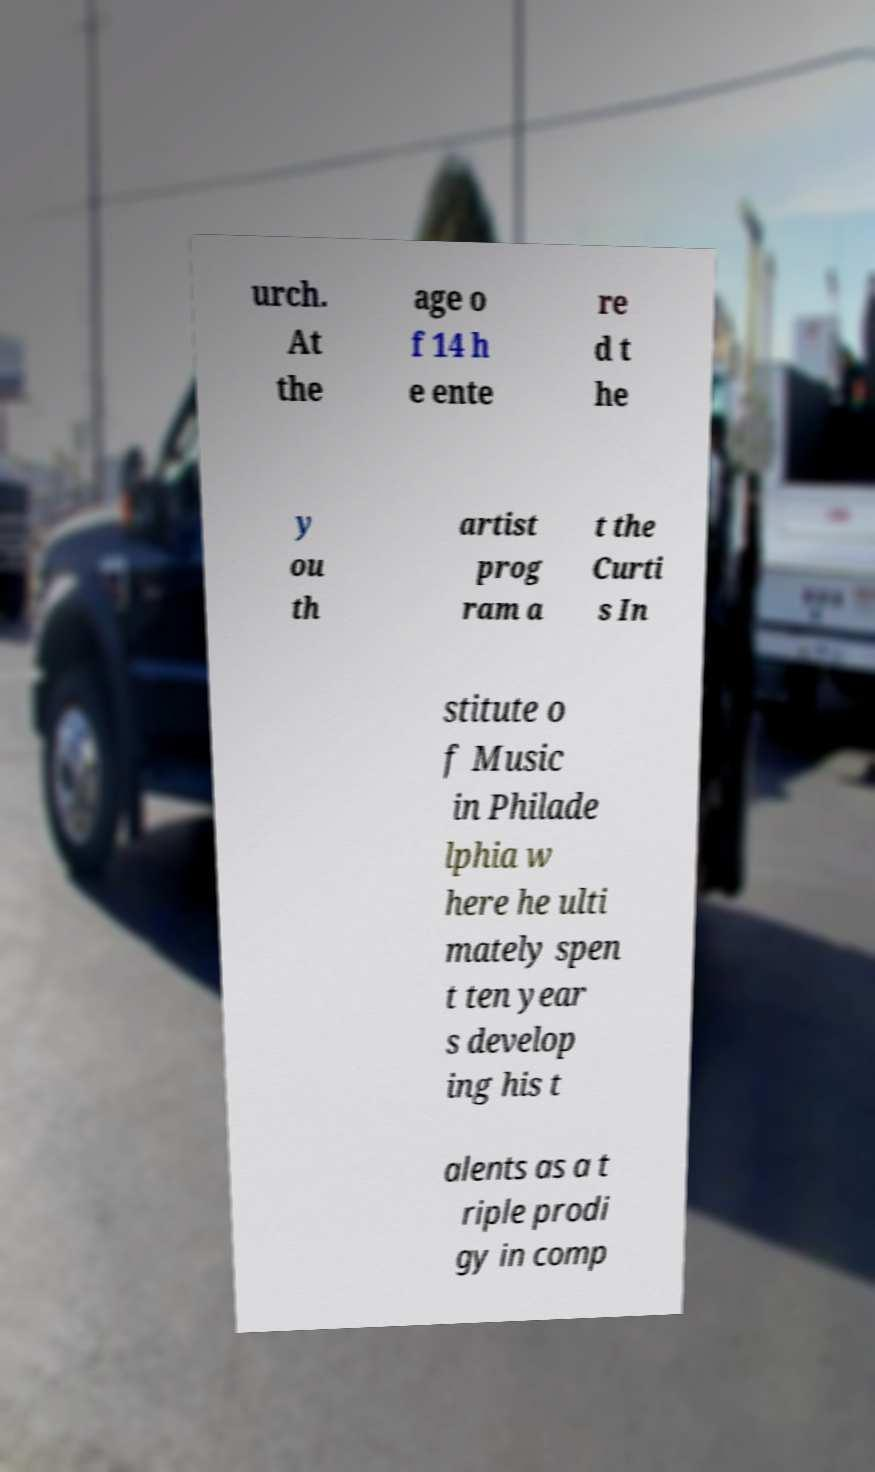Could you assist in decoding the text presented in this image and type it out clearly? urch. At the age o f 14 h e ente re d t he y ou th artist prog ram a t the Curti s In stitute o f Music in Philade lphia w here he ulti mately spen t ten year s develop ing his t alents as a t riple prodi gy in comp 